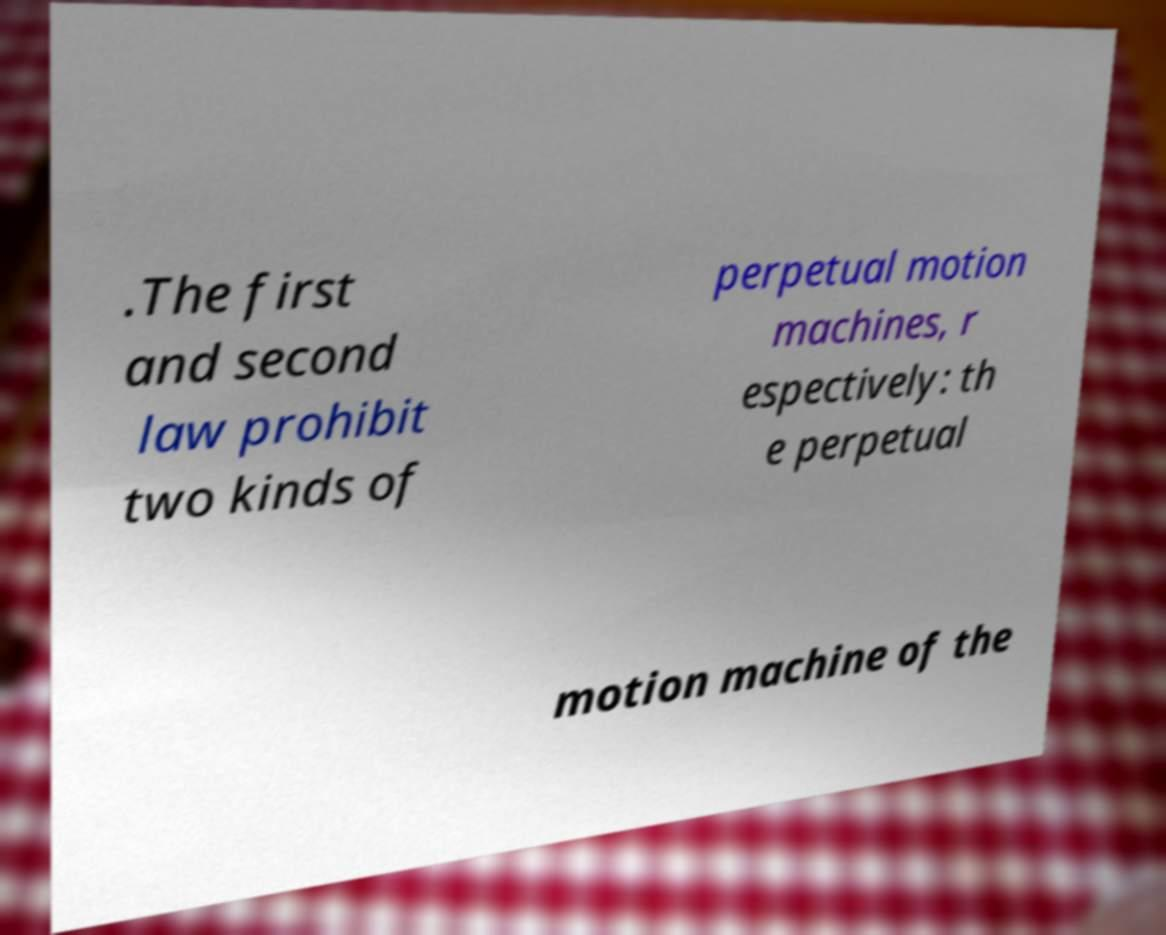Can you read and provide the text displayed in the image?This photo seems to have some interesting text. Can you extract and type it out for me? .The first and second law prohibit two kinds of perpetual motion machines, r espectively: th e perpetual motion machine of the 